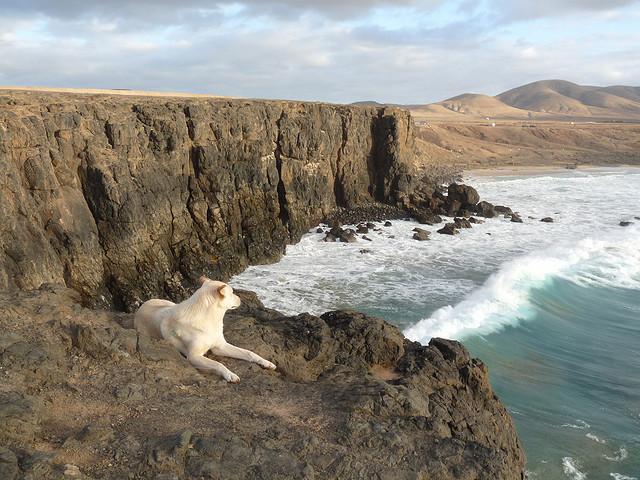How many cars is the train pulling?
Give a very brief answer. 0. 